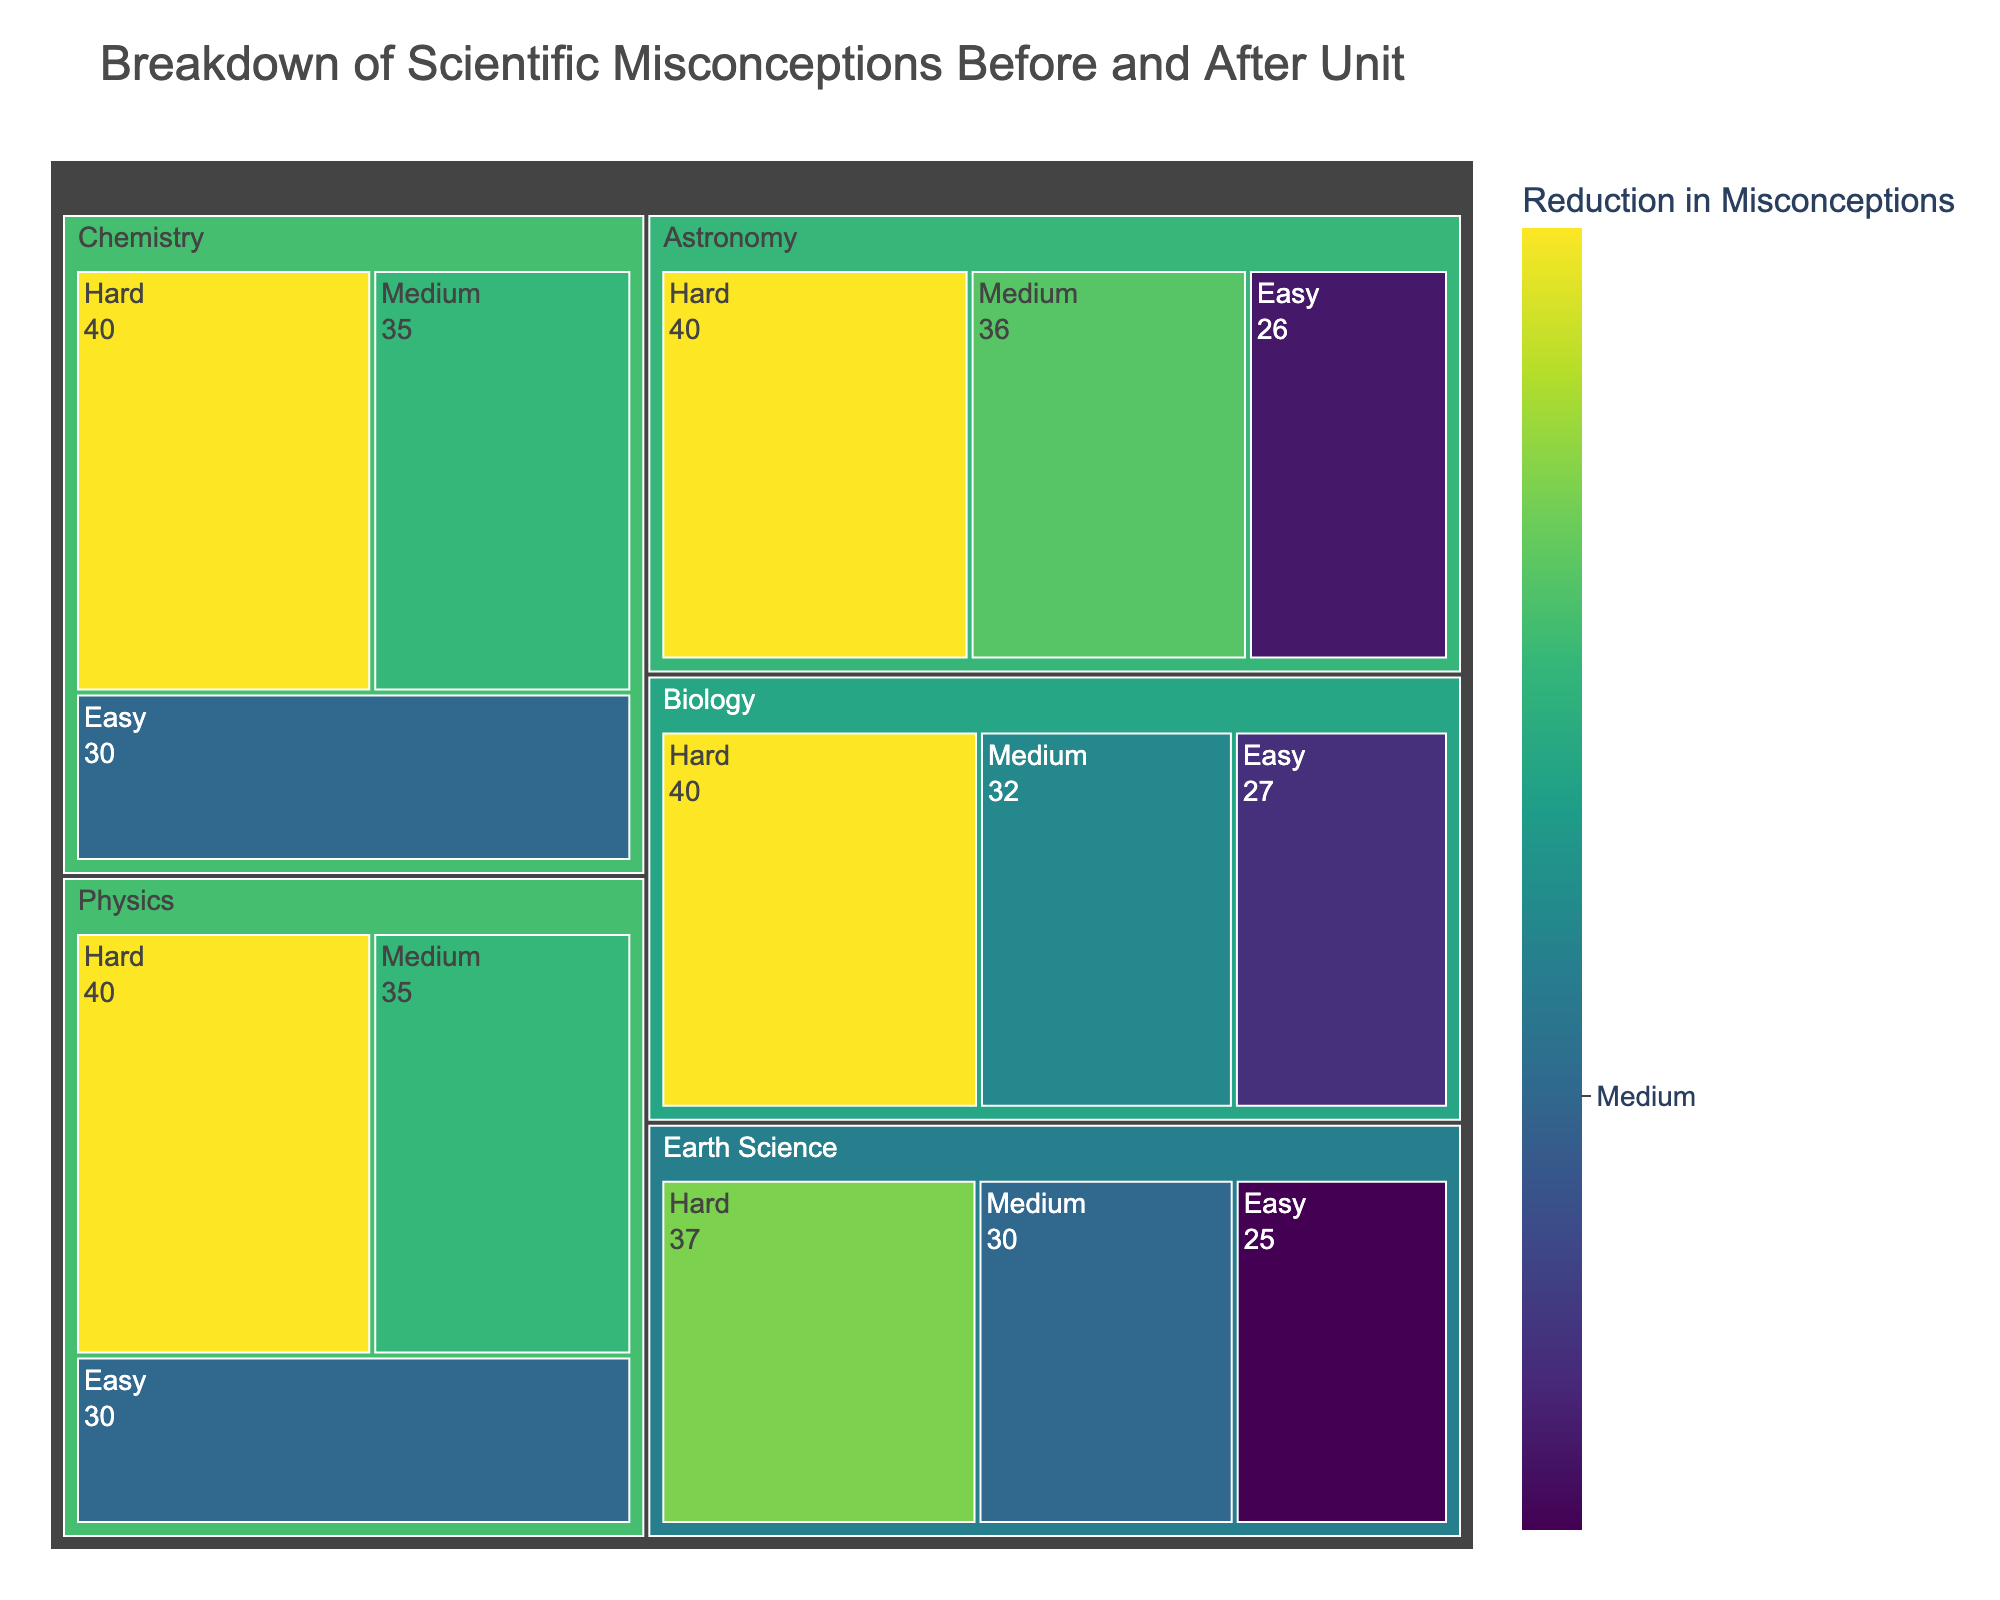What's the title of the figure? The title is displayed at the top of the figure.
Answer: Breakdown of Scientific Misconceptions Before and After Unit What subject area shows the highest reduction in misconceptions? Look for the largest size (area) or the darkest color within the treemap.
Answer: Physics How did the misconceptions in Chemistry for the Medium difficulty level change after the unit? Hover over the Chemistry - Medium section to see the number of misconceptions before and after.
Answer: Reduced from 55 to 20 Which difficulty level in Astronomy shows the greatest reduction in misconceptions? Compare the sizes or colors of the boxes within the Astronomy subject area.
Answer: Hard By how many misconceptions did Biology improve in the Hard difficulty level? Find the difference between the before and after values for Biology - Hard.
Answer: 40 How many misconceptions were reduced collectively in the Easy difficulty across all subjects? Add the size (reduction values) for Easy difficulty levels in each subject.
Answer: 115 Which subject has the least reduction in misconceptions for the Medium difficulty level? Find the smallest size or lightest color in the Medium difficulty level across all subjects.
Answer: Earth Science Why do Physics and Astronomy have similar colors in their Hard difficulty levels? Both subjects in Hard difficulty levels have similar reduction sizes, leading to similar colors.
Answer: Similar reduction sizes Describe the legend for the color axis on this figure. The legend on the color axis provides a title, side indication, tick values with labels, and tick marks pointing outward.
Answer: Reduction in Misconceptions with ticks "Small," "Medium," and "Large" 